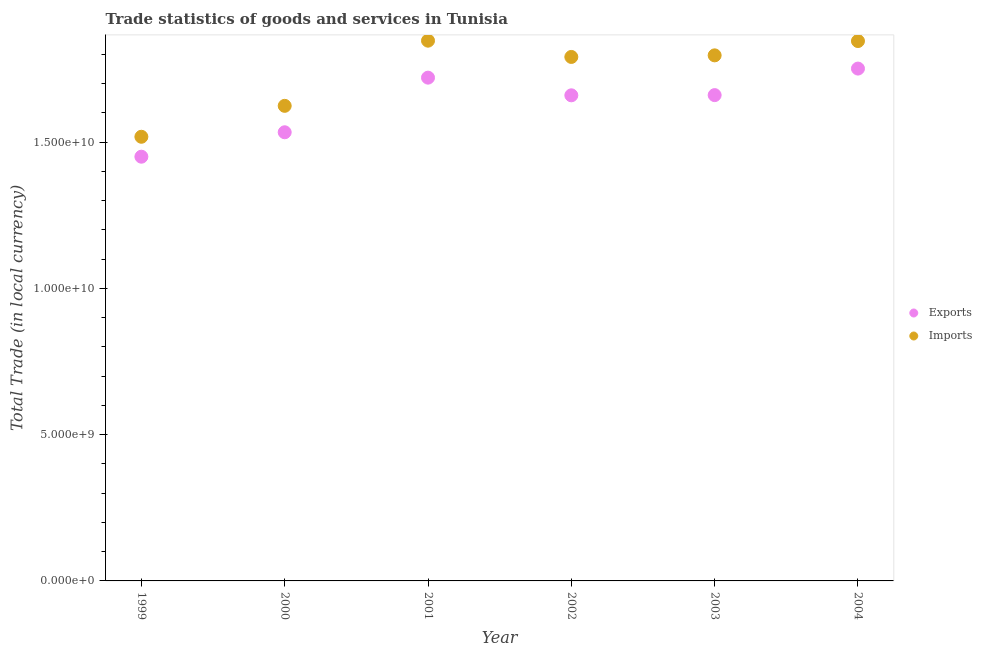How many different coloured dotlines are there?
Ensure brevity in your answer.  2. Is the number of dotlines equal to the number of legend labels?
Offer a terse response. Yes. What is the imports of goods and services in 1999?
Your response must be concise. 1.52e+1. Across all years, what is the maximum export of goods and services?
Your answer should be very brief. 1.75e+1. Across all years, what is the minimum imports of goods and services?
Ensure brevity in your answer.  1.52e+1. In which year was the export of goods and services maximum?
Keep it short and to the point. 2004. In which year was the export of goods and services minimum?
Offer a terse response. 1999. What is the total imports of goods and services in the graph?
Your response must be concise. 1.04e+11. What is the difference between the export of goods and services in 2001 and that in 2002?
Keep it short and to the point. 6.04e+08. What is the difference between the imports of goods and services in 2003 and the export of goods and services in 2002?
Your answer should be very brief. 1.37e+09. What is the average export of goods and services per year?
Offer a terse response. 1.63e+1. In the year 2004, what is the difference between the export of goods and services and imports of goods and services?
Give a very brief answer. -9.41e+08. In how many years, is the export of goods and services greater than 2000000000 LCU?
Keep it short and to the point. 6. What is the ratio of the export of goods and services in 1999 to that in 2004?
Your response must be concise. 0.83. Is the difference between the imports of goods and services in 2003 and 2004 greater than the difference between the export of goods and services in 2003 and 2004?
Your answer should be compact. Yes. What is the difference between the highest and the second highest export of goods and services?
Give a very brief answer. 3.10e+08. What is the difference between the highest and the lowest imports of goods and services?
Provide a succinct answer. 3.28e+09. Is the sum of the imports of goods and services in 2000 and 2002 greater than the maximum export of goods and services across all years?
Make the answer very short. Yes. How many years are there in the graph?
Your response must be concise. 6. What is the difference between two consecutive major ticks on the Y-axis?
Make the answer very short. 5.00e+09. Does the graph contain grids?
Offer a very short reply. No. What is the title of the graph?
Provide a succinct answer. Trade statistics of goods and services in Tunisia. Does "Malaria" appear as one of the legend labels in the graph?
Provide a short and direct response. No. What is the label or title of the X-axis?
Keep it short and to the point. Year. What is the label or title of the Y-axis?
Give a very brief answer. Total Trade (in local currency). What is the Total Trade (in local currency) in Exports in 1999?
Provide a short and direct response. 1.45e+1. What is the Total Trade (in local currency) in Imports in 1999?
Provide a short and direct response. 1.52e+1. What is the Total Trade (in local currency) of Exports in 2000?
Provide a short and direct response. 1.53e+1. What is the Total Trade (in local currency) of Imports in 2000?
Your response must be concise. 1.62e+1. What is the Total Trade (in local currency) of Exports in 2001?
Ensure brevity in your answer.  1.72e+1. What is the Total Trade (in local currency) of Imports in 2001?
Your answer should be very brief. 1.85e+1. What is the Total Trade (in local currency) in Exports in 2002?
Provide a short and direct response. 1.66e+1. What is the Total Trade (in local currency) of Imports in 2002?
Provide a succinct answer. 1.79e+1. What is the Total Trade (in local currency) in Exports in 2003?
Ensure brevity in your answer.  1.66e+1. What is the Total Trade (in local currency) of Imports in 2003?
Provide a short and direct response. 1.80e+1. What is the Total Trade (in local currency) of Exports in 2004?
Your response must be concise. 1.75e+1. What is the Total Trade (in local currency) in Imports in 2004?
Make the answer very short. 1.85e+1. Across all years, what is the maximum Total Trade (in local currency) of Exports?
Provide a short and direct response. 1.75e+1. Across all years, what is the maximum Total Trade (in local currency) of Imports?
Your answer should be very brief. 1.85e+1. Across all years, what is the minimum Total Trade (in local currency) of Exports?
Make the answer very short. 1.45e+1. Across all years, what is the minimum Total Trade (in local currency) of Imports?
Offer a terse response. 1.52e+1. What is the total Total Trade (in local currency) in Exports in the graph?
Give a very brief answer. 9.77e+1. What is the total Total Trade (in local currency) of Imports in the graph?
Provide a succinct answer. 1.04e+11. What is the difference between the Total Trade (in local currency) in Exports in 1999 and that in 2000?
Offer a very short reply. -8.35e+08. What is the difference between the Total Trade (in local currency) in Imports in 1999 and that in 2000?
Keep it short and to the point. -1.06e+09. What is the difference between the Total Trade (in local currency) of Exports in 1999 and that in 2001?
Give a very brief answer. -2.70e+09. What is the difference between the Total Trade (in local currency) of Imports in 1999 and that in 2001?
Provide a short and direct response. -3.28e+09. What is the difference between the Total Trade (in local currency) of Exports in 1999 and that in 2002?
Offer a very short reply. -2.10e+09. What is the difference between the Total Trade (in local currency) of Imports in 1999 and that in 2002?
Provide a succinct answer. -2.73e+09. What is the difference between the Total Trade (in local currency) in Exports in 1999 and that in 2003?
Offer a very short reply. -2.10e+09. What is the difference between the Total Trade (in local currency) in Imports in 1999 and that in 2003?
Make the answer very short. -2.78e+09. What is the difference between the Total Trade (in local currency) of Exports in 1999 and that in 2004?
Provide a succinct answer. -3.01e+09. What is the difference between the Total Trade (in local currency) in Imports in 1999 and that in 2004?
Make the answer very short. -3.27e+09. What is the difference between the Total Trade (in local currency) in Exports in 2000 and that in 2001?
Offer a very short reply. -1.87e+09. What is the difference between the Total Trade (in local currency) in Imports in 2000 and that in 2001?
Provide a short and direct response. -2.23e+09. What is the difference between the Total Trade (in local currency) in Exports in 2000 and that in 2002?
Your answer should be very brief. -1.26e+09. What is the difference between the Total Trade (in local currency) of Imports in 2000 and that in 2002?
Your answer should be very brief. -1.67e+09. What is the difference between the Total Trade (in local currency) in Exports in 2000 and that in 2003?
Ensure brevity in your answer.  -1.27e+09. What is the difference between the Total Trade (in local currency) in Imports in 2000 and that in 2003?
Your response must be concise. -1.73e+09. What is the difference between the Total Trade (in local currency) of Exports in 2000 and that in 2004?
Your answer should be compact. -2.18e+09. What is the difference between the Total Trade (in local currency) of Imports in 2000 and that in 2004?
Provide a succinct answer. -2.21e+09. What is the difference between the Total Trade (in local currency) in Exports in 2001 and that in 2002?
Provide a succinct answer. 6.04e+08. What is the difference between the Total Trade (in local currency) of Imports in 2001 and that in 2002?
Keep it short and to the point. 5.56e+08. What is the difference between the Total Trade (in local currency) of Exports in 2001 and that in 2003?
Ensure brevity in your answer.  5.97e+08. What is the difference between the Total Trade (in local currency) of Imports in 2001 and that in 2003?
Your answer should be very brief. 5.02e+08. What is the difference between the Total Trade (in local currency) in Exports in 2001 and that in 2004?
Your answer should be very brief. -3.10e+08. What is the difference between the Total Trade (in local currency) in Imports in 2001 and that in 2004?
Keep it short and to the point. 1.27e+07. What is the difference between the Total Trade (in local currency) of Exports in 2002 and that in 2003?
Provide a short and direct response. -7.17e+06. What is the difference between the Total Trade (in local currency) of Imports in 2002 and that in 2003?
Your answer should be very brief. -5.42e+07. What is the difference between the Total Trade (in local currency) in Exports in 2002 and that in 2004?
Keep it short and to the point. -9.14e+08. What is the difference between the Total Trade (in local currency) of Imports in 2002 and that in 2004?
Make the answer very short. -5.43e+08. What is the difference between the Total Trade (in local currency) of Exports in 2003 and that in 2004?
Provide a short and direct response. -9.07e+08. What is the difference between the Total Trade (in local currency) of Imports in 2003 and that in 2004?
Ensure brevity in your answer.  -4.89e+08. What is the difference between the Total Trade (in local currency) of Exports in 1999 and the Total Trade (in local currency) of Imports in 2000?
Provide a short and direct response. -1.74e+09. What is the difference between the Total Trade (in local currency) of Exports in 1999 and the Total Trade (in local currency) of Imports in 2001?
Provide a succinct answer. -3.97e+09. What is the difference between the Total Trade (in local currency) of Exports in 1999 and the Total Trade (in local currency) of Imports in 2002?
Offer a terse response. -3.41e+09. What is the difference between the Total Trade (in local currency) of Exports in 1999 and the Total Trade (in local currency) of Imports in 2003?
Offer a terse response. -3.46e+09. What is the difference between the Total Trade (in local currency) in Exports in 1999 and the Total Trade (in local currency) in Imports in 2004?
Keep it short and to the point. -3.95e+09. What is the difference between the Total Trade (in local currency) in Exports in 2000 and the Total Trade (in local currency) in Imports in 2001?
Keep it short and to the point. -3.13e+09. What is the difference between the Total Trade (in local currency) in Exports in 2000 and the Total Trade (in local currency) in Imports in 2002?
Your answer should be compact. -2.57e+09. What is the difference between the Total Trade (in local currency) of Exports in 2000 and the Total Trade (in local currency) of Imports in 2003?
Keep it short and to the point. -2.63e+09. What is the difference between the Total Trade (in local currency) in Exports in 2000 and the Total Trade (in local currency) in Imports in 2004?
Your response must be concise. -3.12e+09. What is the difference between the Total Trade (in local currency) in Exports in 2001 and the Total Trade (in local currency) in Imports in 2002?
Ensure brevity in your answer.  -7.08e+08. What is the difference between the Total Trade (in local currency) of Exports in 2001 and the Total Trade (in local currency) of Imports in 2003?
Your response must be concise. -7.62e+08. What is the difference between the Total Trade (in local currency) in Exports in 2001 and the Total Trade (in local currency) in Imports in 2004?
Offer a very short reply. -1.25e+09. What is the difference between the Total Trade (in local currency) in Exports in 2002 and the Total Trade (in local currency) in Imports in 2003?
Offer a very short reply. -1.37e+09. What is the difference between the Total Trade (in local currency) of Exports in 2002 and the Total Trade (in local currency) of Imports in 2004?
Your answer should be very brief. -1.85e+09. What is the difference between the Total Trade (in local currency) of Exports in 2003 and the Total Trade (in local currency) of Imports in 2004?
Provide a short and direct response. -1.85e+09. What is the average Total Trade (in local currency) in Exports per year?
Ensure brevity in your answer.  1.63e+1. What is the average Total Trade (in local currency) in Imports per year?
Your response must be concise. 1.74e+1. In the year 1999, what is the difference between the Total Trade (in local currency) of Exports and Total Trade (in local currency) of Imports?
Ensure brevity in your answer.  -6.81e+08. In the year 2000, what is the difference between the Total Trade (in local currency) in Exports and Total Trade (in local currency) in Imports?
Provide a short and direct response. -9.03e+08. In the year 2001, what is the difference between the Total Trade (in local currency) of Exports and Total Trade (in local currency) of Imports?
Your response must be concise. -1.26e+09. In the year 2002, what is the difference between the Total Trade (in local currency) in Exports and Total Trade (in local currency) in Imports?
Keep it short and to the point. -1.31e+09. In the year 2003, what is the difference between the Total Trade (in local currency) in Exports and Total Trade (in local currency) in Imports?
Keep it short and to the point. -1.36e+09. In the year 2004, what is the difference between the Total Trade (in local currency) in Exports and Total Trade (in local currency) in Imports?
Offer a terse response. -9.41e+08. What is the ratio of the Total Trade (in local currency) in Exports in 1999 to that in 2000?
Make the answer very short. 0.95. What is the ratio of the Total Trade (in local currency) of Imports in 1999 to that in 2000?
Keep it short and to the point. 0.93. What is the ratio of the Total Trade (in local currency) of Exports in 1999 to that in 2001?
Offer a very short reply. 0.84. What is the ratio of the Total Trade (in local currency) of Imports in 1999 to that in 2001?
Provide a succinct answer. 0.82. What is the ratio of the Total Trade (in local currency) of Exports in 1999 to that in 2002?
Your answer should be very brief. 0.87. What is the ratio of the Total Trade (in local currency) in Imports in 1999 to that in 2002?
Give a very brief answer. 0.85. What is the ratio of the Total Trade (in local currency) of Exports in 1999 to that in 2003?
Your answer should be compact. 0.87. What is the ratio of the Total Trade (in local currency) of Imports in 1999 to that in 2003?
Make the answer very short. 0.85. What is the ratio of the Total Trade (in local currency) in Exports in 1999 to that in 2004?
Provide a short and direct response. 0.83. What is the ratio of the Total Trade (in local currency) in Imports in 1999 to that in 2004?
Keep it short and to the point. 0.82. What is the ratio of the Total Trade (in local currency) in Exports in 2000 to that in 2001?
Ensure brevity in your answer.  0.89. What is the ratio of the Total Trade (in local currency) in Imports in 2000 to that in 2001?
Provide a short and direct response. 0.88. What is the ratio of the Total Trade (in local currency) in Exports in 2000 to that in 2002?
Make the answer very short. 0.92. What is the ratio of the Total Trade (in local currency) of Imports in 2000 to that in 2002?
Make the answer very short. 0.91. What is the ratio of the Total Trade (in local currency) of Exports in 2000 to that in 2003?
Make the answer very short. 0.92. What is the ratio of the Total Trade (in local currency) of Imports in 2000 to that in 2003?
Your answer should be very brief. 0.9. What is the ratio of the Total Trade (in local currency) in Exports in 2000 to that in 2004?
Offer a terse response. 0.88. What is the ratio of the Total Trade (in local currency) in Exports in 2001 to that in 2002?
Provide a succinct answer. 1.04. What is the ratio of the Total Trade (in local currency) of Imports in 2001 to that in 2002?
Keep it short and to the point. 1.03. What is the ratio of the Total Trade (in local currency) of Exports in 2001 to that in 2003?
Your answer should be very brief. 1.04. What is the ratio of the Total Trade (in local currency) of Imports in 2001 to that in 2003?
Your response must be concise. 1.03. What is the ratio of the Total Trade (in local currency) of Exports in 2001 to that in 2004?
Provide a succinct answer. 0.98. What is the ratio of the Total Trade (in local currency) of Imports in 2001 to that in 2004?
Give a very brief answer. 1. What is the ratio of the Total Trade (in local currency) of Exports in 2002 to that in 2004?
Provide a succinct answer. 0.95. What is the ratio of the Total Trade (in local currency) in Imports in 2002 to that in 2004?
Offer a very short reply. 0.97. What is the ratio of the Total Trade (in local currency) in Exports in 2003 to that in 2004?
Provide a succinct answer. 0.95. What is the ratio of the Total Trade (in local currency) of Imports in 2003 to that in 2004?
Offer a terse response. 0.97. What is the difference between the highest and the second highest Total Trade (in local currency) of Exports?
Offer a very short reply. 3.10e+08. What is the difference between the highest and the second highest Total Trade (in local currency) in Imports?
Keep it short and to the point. 1.27e+07. What is the difference between the highest and the lowest Total Trade (in local currency) of Exports?
Provide a short and direct response. 3.01e+09. What is the difference between the highest and the lowest Total Trade (in local currency) in Imports?
Offer a very short reply. 3.28e+09. 